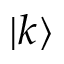Convert formula to latex. <formula><loc_0><loc_0><loc_500><loc_500>| k \rangle</formula> 